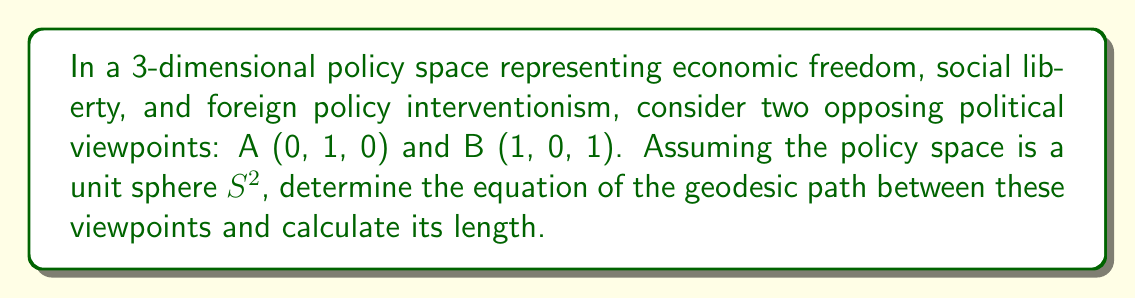Teach me how to tackle this problem. 1) On a unit sphere $S^2$, geodesics are great circles. The equation of a great circle passing through two points can be found using the cross product of their position vectors.

2) Let $\vec{a} = (0, 1, 0)$ and $\vec{b} = (1, 0, 1)$ be the position vectors of A and B.

3) Calculate the cross product:
   $$\vec{n} = \vec{a} \times \vec{b} = (1, -1, -1)$$

4) The equation of the plane containing this great circle is:
   $$nx + ny + nz = 0$$
   $$x - y - z = 0$$

5) This plane intersects the unit sphere to form the geodesic. The parametric equations of the geodesic are:
   $$x(t) = \cos t$$
   $$y(t) = \frac{1}{\sqrt{2}}\sin t$$
   $$z(t) = -\frac{1}{\sqrt{2}}\sin t$$

6) To find the length of the geodesic, we need to find the angle $\theta$ between $\vec{a}$ and $\vec{b}$:
   $$\cos \theta = \frac{\vec{a} \cdot \vec{b}}{|\vec{a}||\vec{b}|} = \frac{0}{\sqrt{1}\sqrt{2}} = 0$$

7) Therefore, $\theta = \frac{\pi}{2}$.

8) The length of the geodesic on a unit sphere is equal to the central angle in radians. So the length is $\frac{\pi}{2}$.
Answer: Geodesic equation: $x - y - z = 0$; Length: $\frac{\pi}{2}$ 